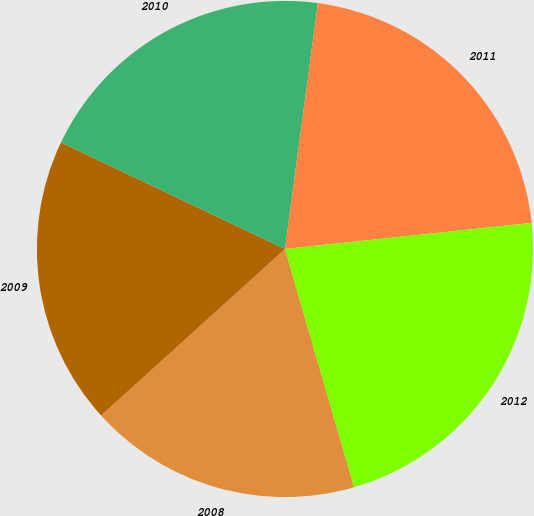<chart> <loc_0><loc_0><loc_500><loc_500><pie_chart><fcel>2008<fcel>2009<fcel>2010<fcel>2011<fcel>2012<nl><fcel>17.78%<fcel>18.78%<fcel>20.05%<fcel>21.2%<fcel>22.18%<nl></chart> 